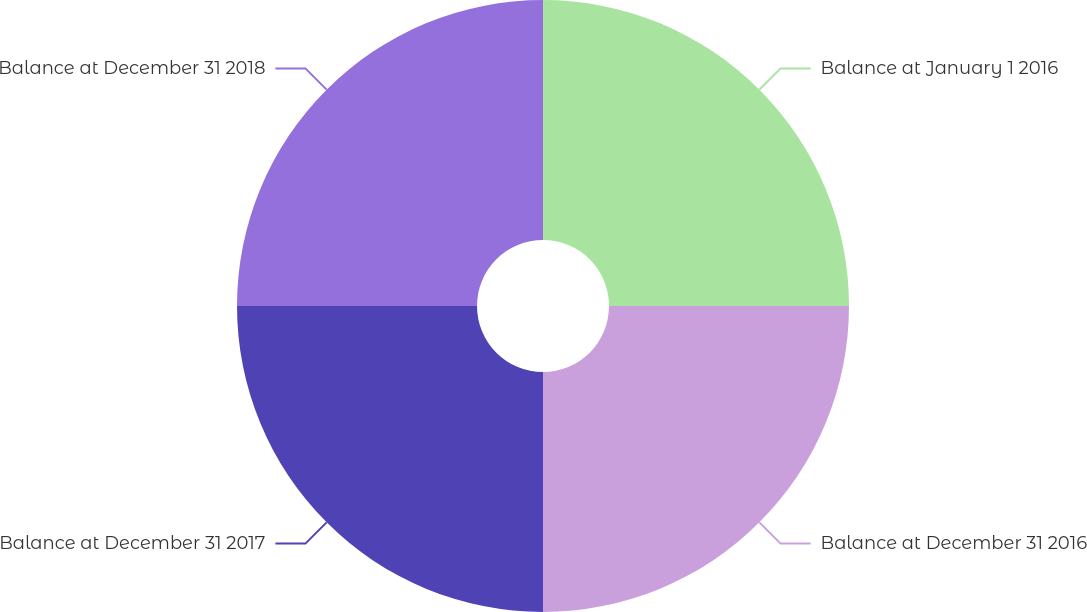<chart> <loc_0><loc_0><loc_500><loc_500><pie_chart><fcel>Balance at January 1 2016<fcel>Balance at December 31 2016<fcel>Balance at December 31 2017<fcel>Balance at December 31 2018<nl><fcel>25.0%<fcel>25.0%<fcel>25.0%<fcel>25.0%<nl></chart> 